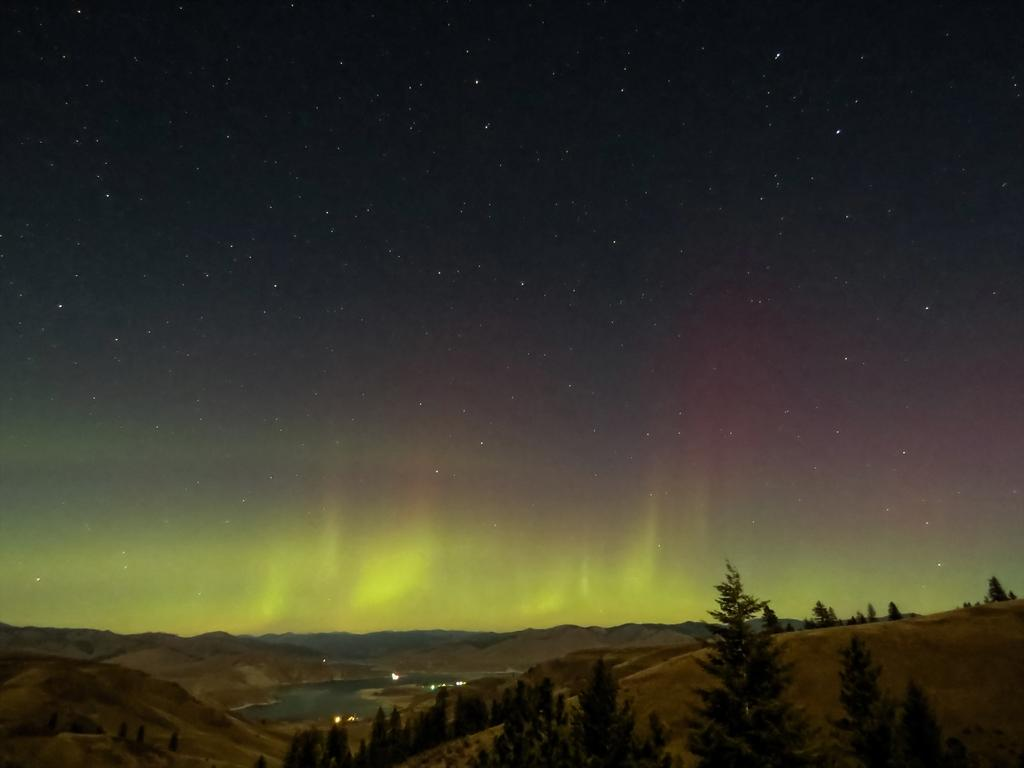What type of vegetation is visible at the bottom side of the image? There are trees at the bottom side of the image. What natural element is visible at the top side of the image? There is sky at the top side of the image. What animal can be seen fighting in the image? There is no animal or fight present in the image; it only features trees at the bottom and sky at the top. 